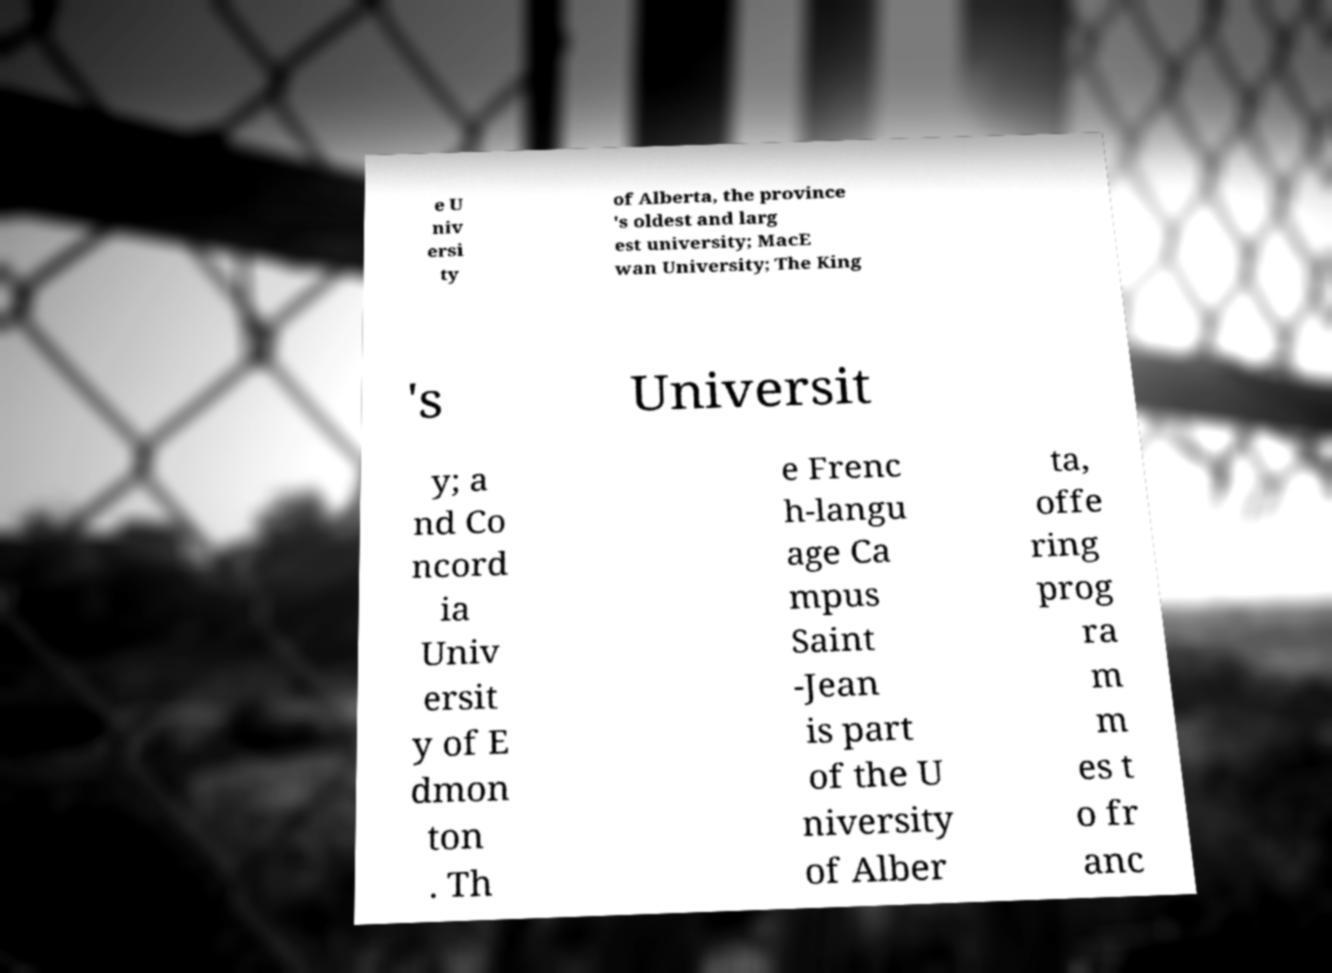I need the written content from this picture converted into text. Can you do that? e U niv ersi ty of Alberta, the province 's oldest and larg est university; MacE wan University; The King 's Universit y; a nd Co ncord ia Univ ersit y of E dmon ton . Th e Frenc h-langu age Ca mpus Saint -Jean is part of the U niversity of Alber ta, offe ring prog ra m m es t o fr anc 